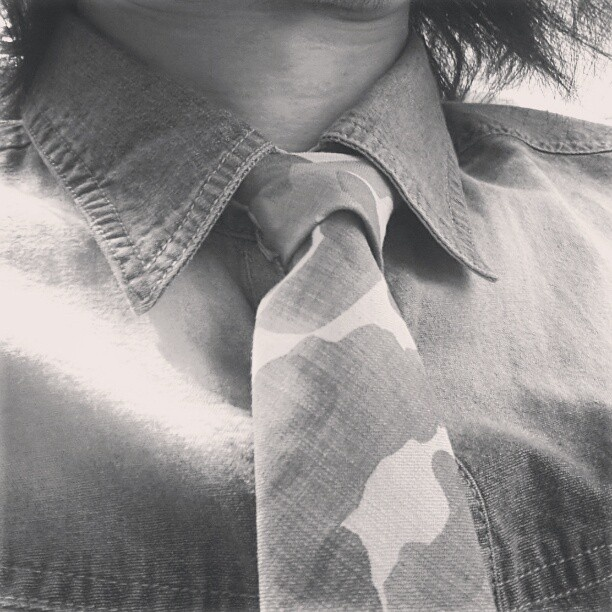Describe the objects in this image and their specific colors. I can see people in gray, darkgray, lightgray, and black tones and tie in darkgray, lightgray, and gray tones in this image. 